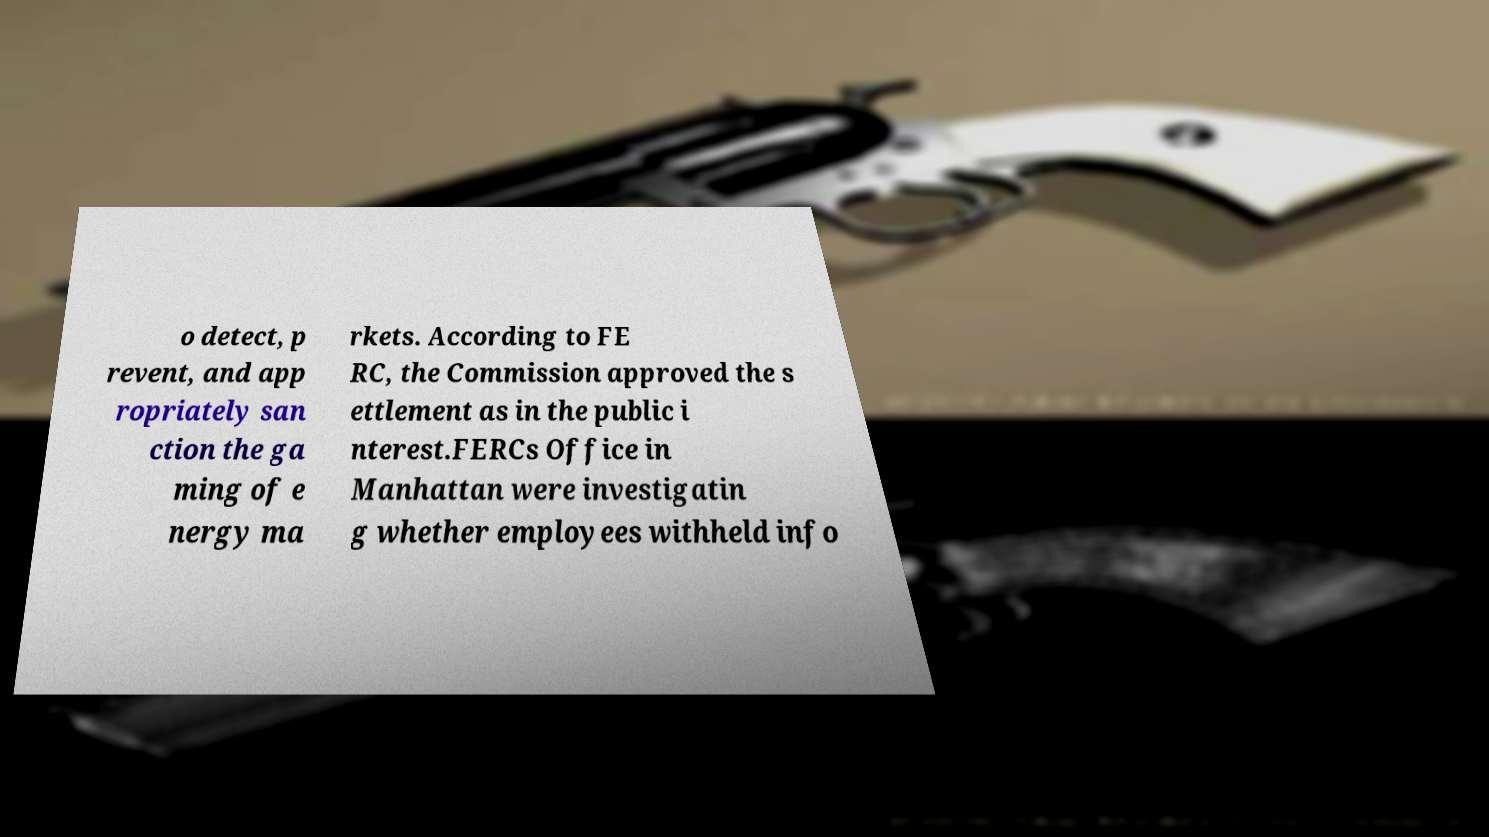Please identify and transcribe the text found in this image. o detect, p revent, and app ropriately san ction the ga ming of e nergy ma rkets. According to FE RC, the Commission approved the s ettlement as in the public i nterest.FERCs Office in Manhattan were investigatin g whether employees withheld info 